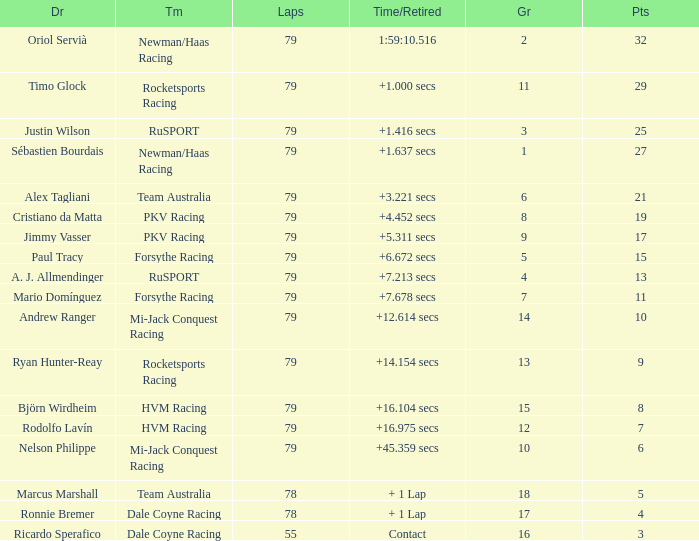What grid has 78 laps, and Ronnie Bremer as driver? 17.0. 